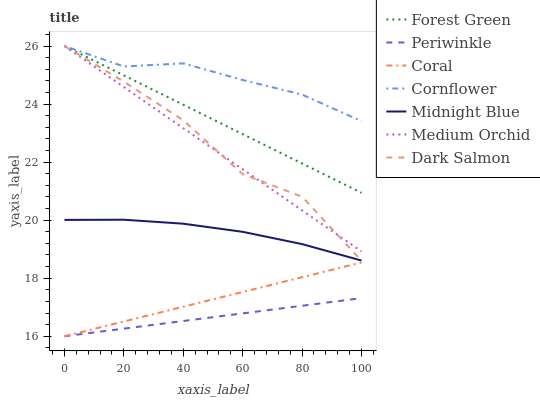Does Periwinkle have the minimum area under the curve?
Answer yes or no. Yes. Does Cornflower have the maximum area under the curve?
Answer yes or no. Yes. Does Midnight Blue have the minimum area under the curve?
Answer yes or no. No. Does Midnight Blue have the maximum area under the curve?
Answer yes or no. No. Is Periwinkle the smoothest?
Answer yes or no. Yes. Is Dark Salmon the roughest?
Answer yes or no. Yes. Is Midnight Blue the smoothest?
Answer yes or no. No. Is Midnight Blue the roughest?
Answer yes or no. No. Does Coral have the lowest value?
Answer yes or no. Yes. Does Midnight Blue have the lowest value?
Answer yes or no. No. Does Forest Green have the highest value?
Answer yes or no. Yes. Does Midnight Blue have the highest value?
Answer yes or no. No. Is Coral less than Dark Salmon?
Answer yes or no. Yes. Is Cornflower greater than Midnight Blue?
Answer yes or no. Yes. Does Periwinkle intersect Coral?
Answer yes or no. Yes. Is Periwinkle less than Coral?
Answer yes or no. No. Is Periwinkle greater than Coral?
Answer yes or no. No. Does Coral intersect Dark Salmon?
Answer yes or no. No. 